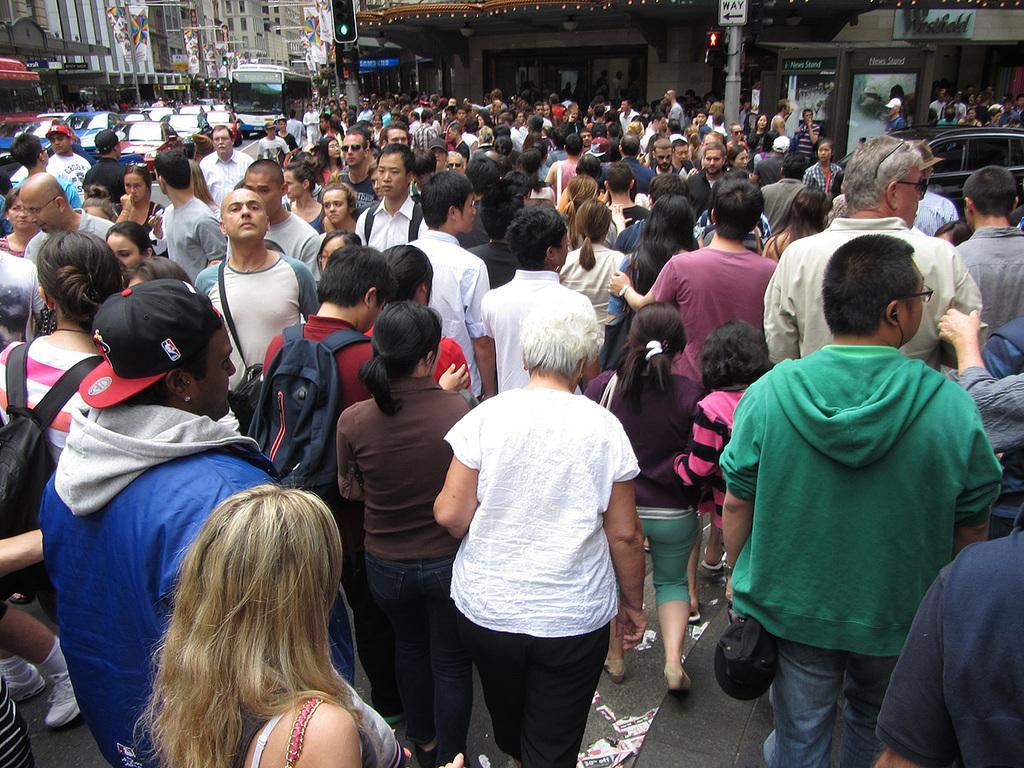Describe this image in one or two sentences. In this image I can see a huge crowd of people standing and walking on the road. I can see signals, poles, cars, other vehicles and buildings in this image. 